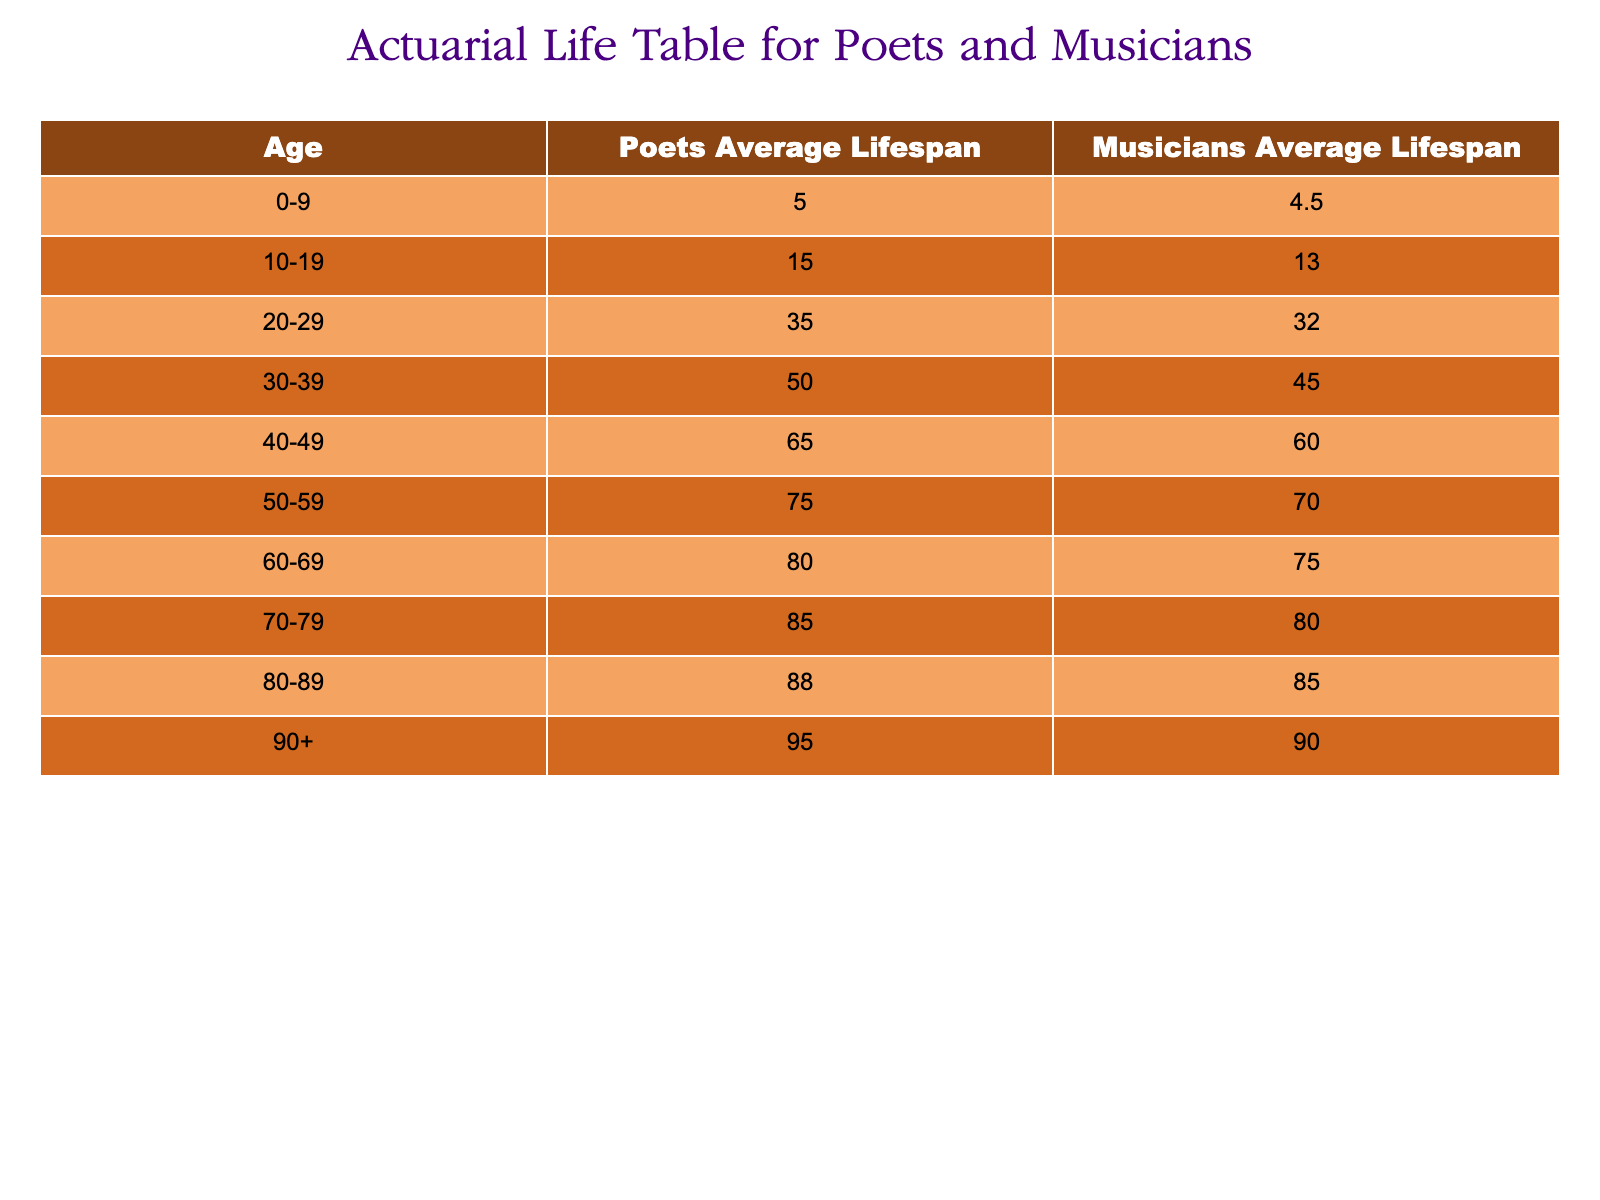What is the average lifespan of poets in their 50s? From the table, the average lifespan of poets in the age group 50-59 is given as 75.0.
Answer: 75.0 How much longer do poets live compared to musicians on average in their 40s? For poets aged 40-49, the average lifespan is 65.0, and for musicians, it is 60.0. The difference is 65.0 - 60.0 = 5.0 years.
Answer: 5.0 years Is the average lifespan of musicians in their 60s greater than that of poets in their 20s? The average lifespan of musicians aged 60-69 is 75.0, while poets aged 20-29 live on average 35.0. Since 75.0 is greater than 35.0, the statement is true.
Answer: Yes What is the combined average lifespan of poets and musicians in their 70s? For poets in the 70-79 range, the average is 85.0 and for musicians it is 80.0. The combined average is (85.0 + 80.0) / 2 = 82.5.
Answer: 82.5 What is the overall average lifespan for musicians across all age groups in the table? To calculate the overall average, sum the average lifespans for musicians: (4.5 + 13.0 + 32.0 + 45.0 + 60.0 + 70.0 + 75.0 + 80.0 + 85.0 + 90.0) = 495.0, and divide by 10, yielding 495.0 / 10 = 49.5.
Answer: 49.5 How many age groups have an average lifespan of more than 80 years for poets? By examining the table, the age groups that exceed an average lifespan of 80 for poets are 70-79 (85.0), 80-89 (88.0), and 90+ (95.0). This gives us a total of 3 groups.
Answer: 3 groups 